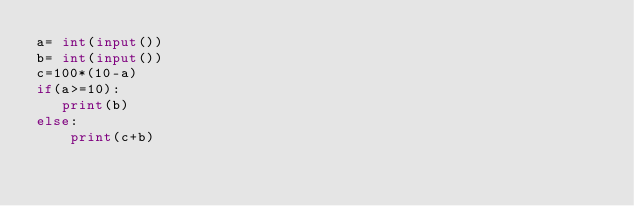Convert code to text. <code><loc_0><loc_0><loc_500><loc_500><_Python_>a= int(input())
b= int(input())
c=100*(10-a)
if(a>=10):
   print(b)
else:
    print(c+b)
</code> 